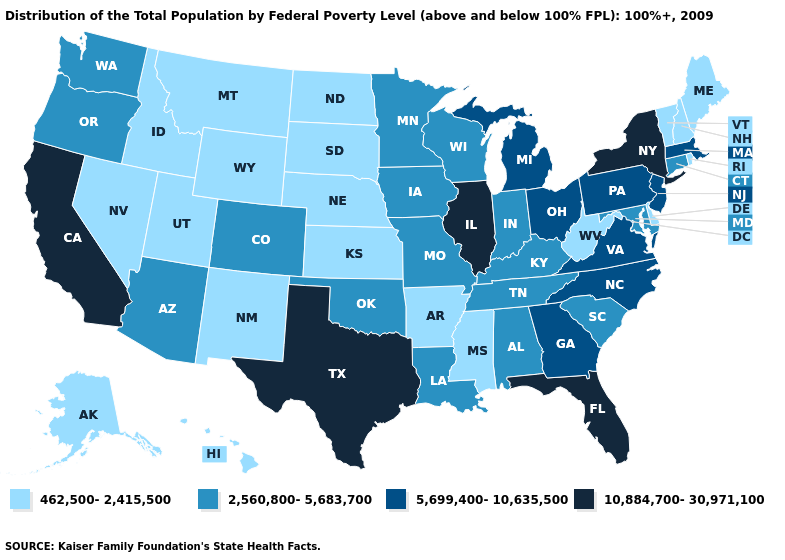Does the map have missing data?
Keep it brief. No. Name the states that have a value in the range 462,500-2,415,500?
Write a very short answer. Alaska, Arkansas, Delaware, Hawaii, Idaho, Kansas, Maine, Mississippi, Montana, Nebraska, Nevada, New Hampshire, New Mexico, North Dakota, Rhode Island, South Dakota, Utah, Vermont, West Virginia, Wyoming. Which states have the highest value in the USA?
Answer briefly. California, Florida, Illinois, New York, Texas. Does California have the lowest value in the West?
Quick response, please. No. Name the states that have a value in the range 2,560,800-5,683,700?
Answer briefly. Alabama, Arizona, Colorado, Connecticut, Indiana, Iowa, Kentucky, Louisiana, Maryland, Minnesota, Missouri, Oklahoma, Oregon, South Carolina, Tennessee, Washington, Wisconsin. Does Rhode Island have the highest value in the Northeast?
Give a very brief answer. No. What is the value of Utah?
Write a very short answer. 462,500-2,415,500. What is the value of Nevada?
Answer briefly. 462,500-2,415,500. Name the states that have a value in the range 2,560,800-5,683,700?
Be succinct. Alabama, Arizona, Colorado, Connecticut, Indiana, Iowa, Kentucky, Louisiana, Maryland, Minnesota, Missouri, Oklahoma, Oregon, South Carolina, Tennessee, Washington, Wisconsin. Does Texas have the highest value in the USA?
Answer briefly. Yes. What is the value of New Hampshire?
Short answer required. 462,500-2,415,500. Does Rhode Island have the same value as Arkansas?
Concise answer only. Yes. Among the states that border New Jersey , which have the highest value?
Keep it brief. New York. 